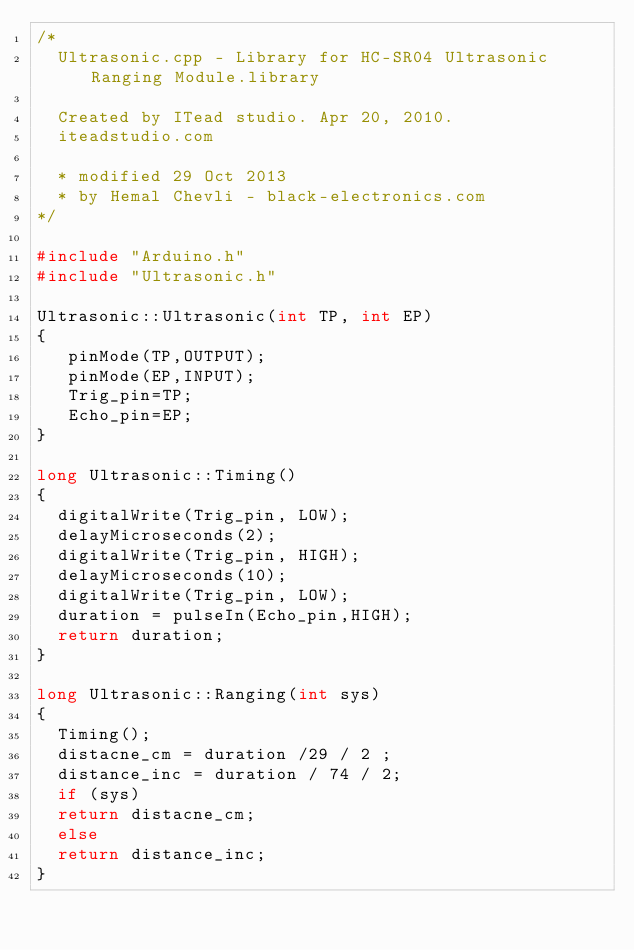Convert code to text. <code><loc_0><loc_0><loc_500><loc_500><_C++_>/*
  Ultrasonic.cpp - Library for HC-SR04 Ultrasonic Ranging Module.library

  Created by ITead studio. Apr 20, 2010.
  iteadstudio.com
  
  * modified 29 Oct 2013
  * by Hemal Chevli - black-electronics.com
*/

#include "Arduino.h"
#include "Ultrasonic.h"

Ultrasonic::Ultrasonic(int TP, int EP)
{
   pinMode(TP,OUTPUT);
   pinMode(EP,INPUT);
   Trig_pin=TP;
   Echo_pin=EP;
}

long Ultrasonic::Timing()
{
  digitalWrite(Trig_pin, LOW);
  delayMicroseconds(2);
  digitalWrite(Trig_pin, HIGH);
  delayMicroseconds(10);
  digitalWrite(Trig_pin, LOW);
  duration = pulseIn(Echo_pin,HIGH);
  return duration;
}

long Ultrasonic::Ranging(int sys)
{
  Timing();
  distacne_cm = duration /29 / 2 ;
  distance_inc = duration / 74 / 2;
  if (sys)
  return distacne_cm;
  else
  return distance_inc;
}
</code> 